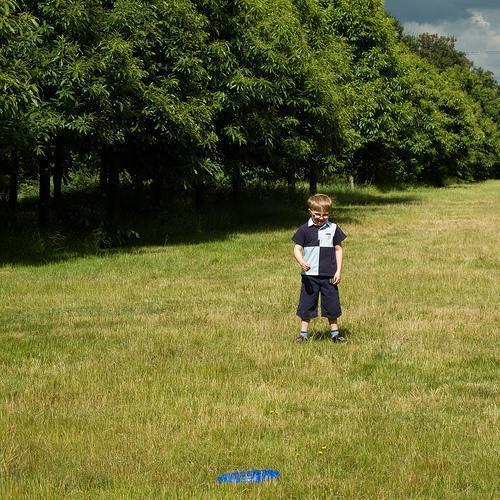How many peoples are shown in the image?
Give a very brief answer. 1. 